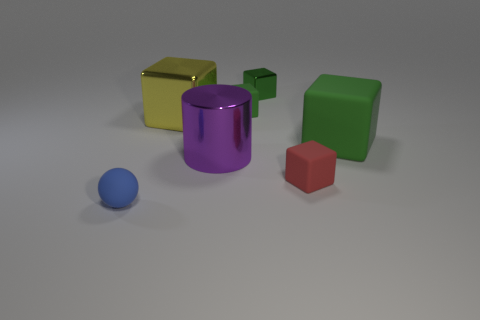Is the color of the tiny shiny thing the same as the big matte cube?
Give a very brief answer. Yes. Is the number of big yellow metallic cubes that are to the right of the large green matte block the same as the number of tiny green things?
Your response must be concise. No. Are there any big cylinders on the left side of the yellow shiny thing?
Your answer should be very brief. No. How many matte objects are yellow blocks or yellow cylinders?
Make the answer very short. 0. What number of green shiny objects are behind the ball?
Your answer should be compact. 1. Are there any green metal blocks that have the same size as the yellow cube?
Your answer should be very brief. No. Is there a small shiny block that has the same color as the big cylinder?
Make the answer very short. No. Is there anything else that is the same size as the blue rubber thing?
Offer a very short reply. Yes. How many small cubes are the same color as the shiny cylinder?
Keep it short and to the point. 0. Is the color of the big cylinder the same as the tiny matte cube behind the yellow metal cube?
Ensure brevity in your answer.  No. 